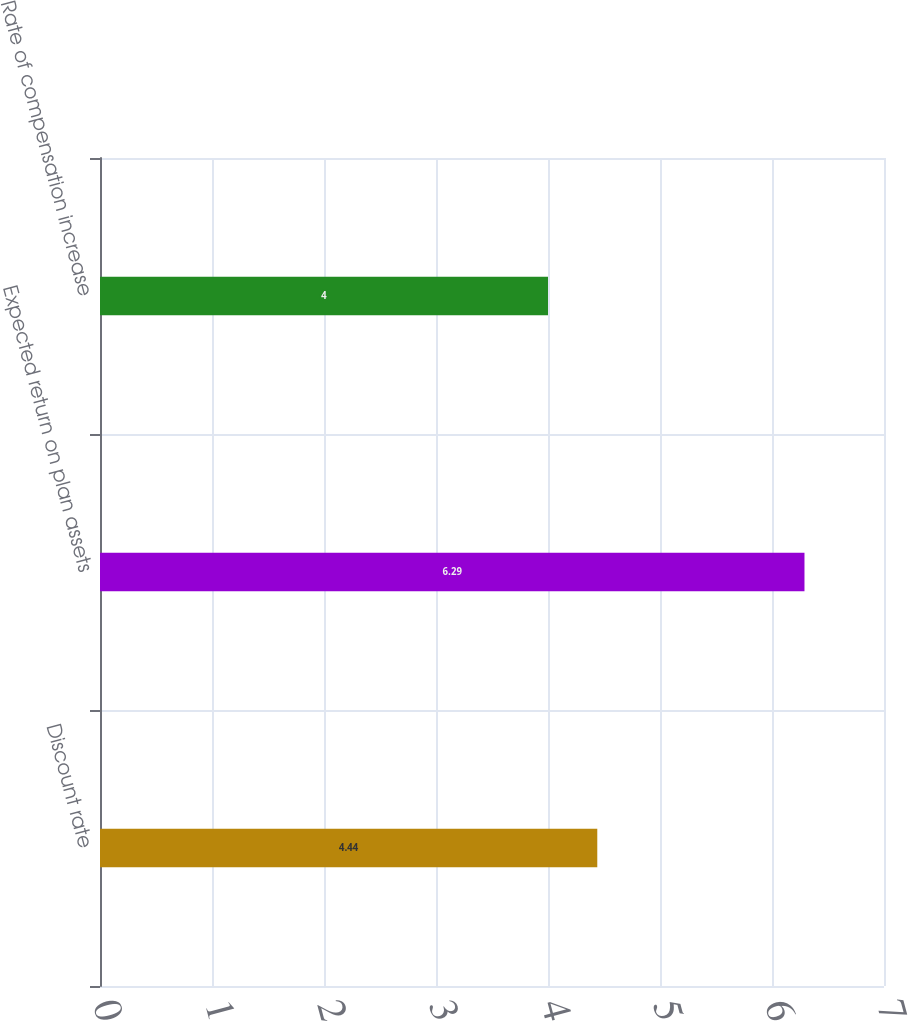<chart> <loc_0><loc_0><loc_500><loc_500><bar_chart><fcel>Discount rate<fcel>Expected return on plan assets<fcel>Rate of compensation increase<nl><fcel>4.44<fcel>6.29<fcel>4<nl></chart> 